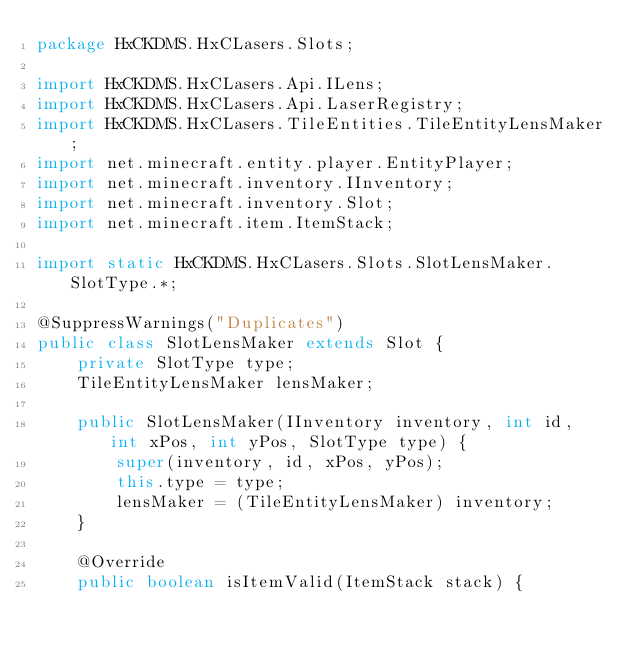Convert code to text. <code><loc_0><loc_0><loc_500><loc_500><_Java_>package HxCKDMS.HxCLasers.Slots;

import HxCKDMS.HxCLasers.Api.ILens;
import HxCKDMS.HxCLasers.Api.LaserRegistry;
import HxCKDMS.HxCLasers.TileEntities.TileEntityLensMaker;
import net.minecraft.entity.player.EntityPlayer;
import net.minecraft.inventory.IInventory;
import net.minecraft.inventory.Slot;
import net.minecraft.item.ItemStack;

import static HxCKDMS.HxCLasers.Slots.SlotLensMaker.SlotType.*;

@SuppressWarnings("Duplicates")
public class SlotLensMaker extends Slot {
    private SlotType type;
    TileEntityLensMaker lensMaker;

    public SlotLensMaker(IInventory inventory, int id, int xPos, int yPos, SlotType type) {
        super(inventory, id, xPos, yPos);
        this.type = type;
        lensMaker = (TileEntityLensMaker) inventory;
    }

    @Override
    public boolean isItemValid(ItemStack stack) {</code> 